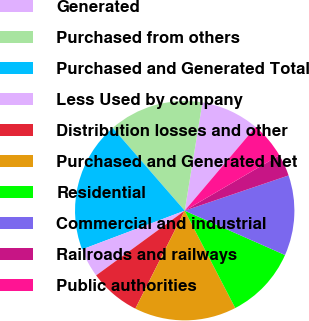Convert chart to OTSL. <chart><loc_0><loc_0><loc_500><loc_500><pie_chart><fcel>Generated<fcel>Purchased from others<fcel>Purchased and Generated Total<fcel>Less Used by company<fcel>Distribution losses and other<fcel>Purchased and Generated Net<fcel>Residential<fcel>Commercial and industrial<fcel>Railroads and railways<fcel>Public authorities<nl><fcel>8.6%<fcel>13.98%<fcel>19.35%<fcel>4.3%<fcel>7.53%<fcel>15.05%<fcel>10.75%<fcel>11.83%<fcel>3.23%<fcel>5.38%<nl></chart> 